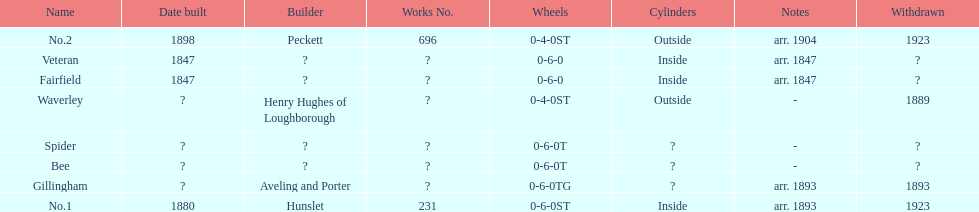Other than fairfield, what else was built in 1847? Veteran. 